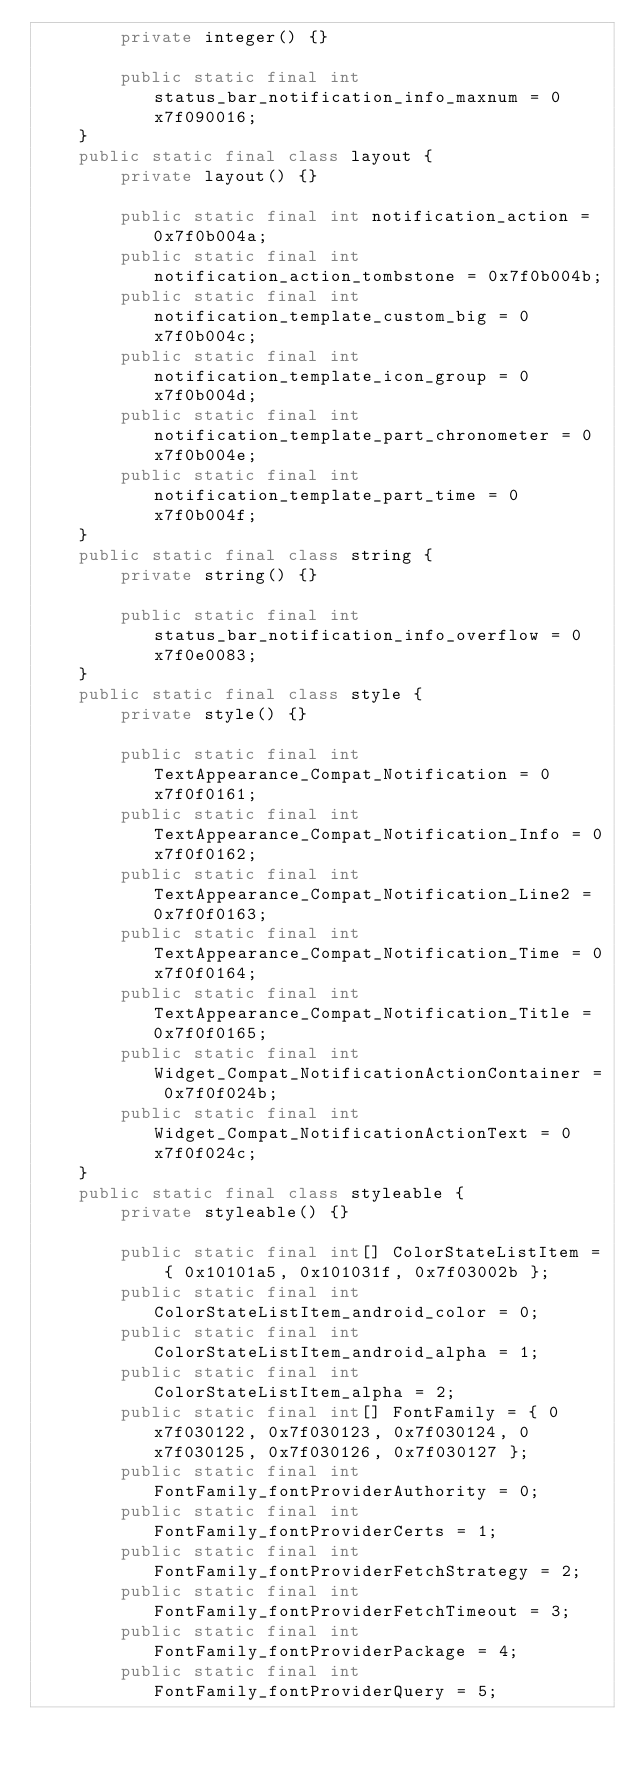Convert code to text. <code><loc_0><loc_0><loc_500><loc_500><_Java_>        private integer() {}

        public static final int status_bar_notification_info_maxnum = 0x7f090016;
    }
    public static final class layout {
        private layout() {}

        public static final int notification_action = 0x7f0b004a;
        public static final int notification_action_tombstone = 0x7f0b004b;
        public static final int notification_template_custom_big = 0x7f0b004c;
        public static final int notification_template_icon_group = 0x7f0b004d;
        public static final int notification_template_part_chronometer = 0x7f0b004e;
        public static final int notification_template_part_time = 0x7f0b004f;
    }
    public static final class string {
        private string() {}

        public static final int status_bar_notification_info_overflow = 0x7f0e0083;
    }
    public static final class style {
        private style() {}

        public static final int TextAppearance_Compat_Notification = 0x7f0f0161;
        public static final int TextAppearance_Compat_Notification_Info = 0x7f0f0162;
        public static final int TextAppearance_Compat_Notification_Line2 = 0x7f0f0163;
        public static final int TextAppearance_Compat_Notification_Time = 0x7f0f0164;
        public static final int TextAppearance_Compat_Notification_Title = 0x7f0f0165;
        public static final int Widget_Compat_NotificationActionContainer = 0x7f0f024b;
        public static final int Widget_Compat_NotificationActionText = 0x7f0f024c;
    }
    public static final class styleable {
        private styleable() {}

        public static final int[] ColorStateListItem = { 0x10101a5, 0x101031f, 0x7f03002b };
        public static final int ColorStateListItem_android_color = 0;
        public static final int ColorStateListItem_android_alpha = 1;
        public static final int ColorStateListItem_alpha = 2;
        public static final int[] FontFamily = { 0x7f030122, 0x7f030123, 0x7f030124, 0x7f030125, 0x7f030126, 0x7f030127 };
        public static final int FontFamily_fontProviderAuthority = 0;
        public static final int FontFamily_fontProviderCerts = 1;
        public static final int FontFamily_fontProviderFetchStrategy = 2;
        public static final int FontFamily_fontProviderFetchTimeout = 3;
        public static final int FontFamily_fontProviderPackage = 4;
        public static final int FontFamily_fontProviderQuery = 5;</code> 